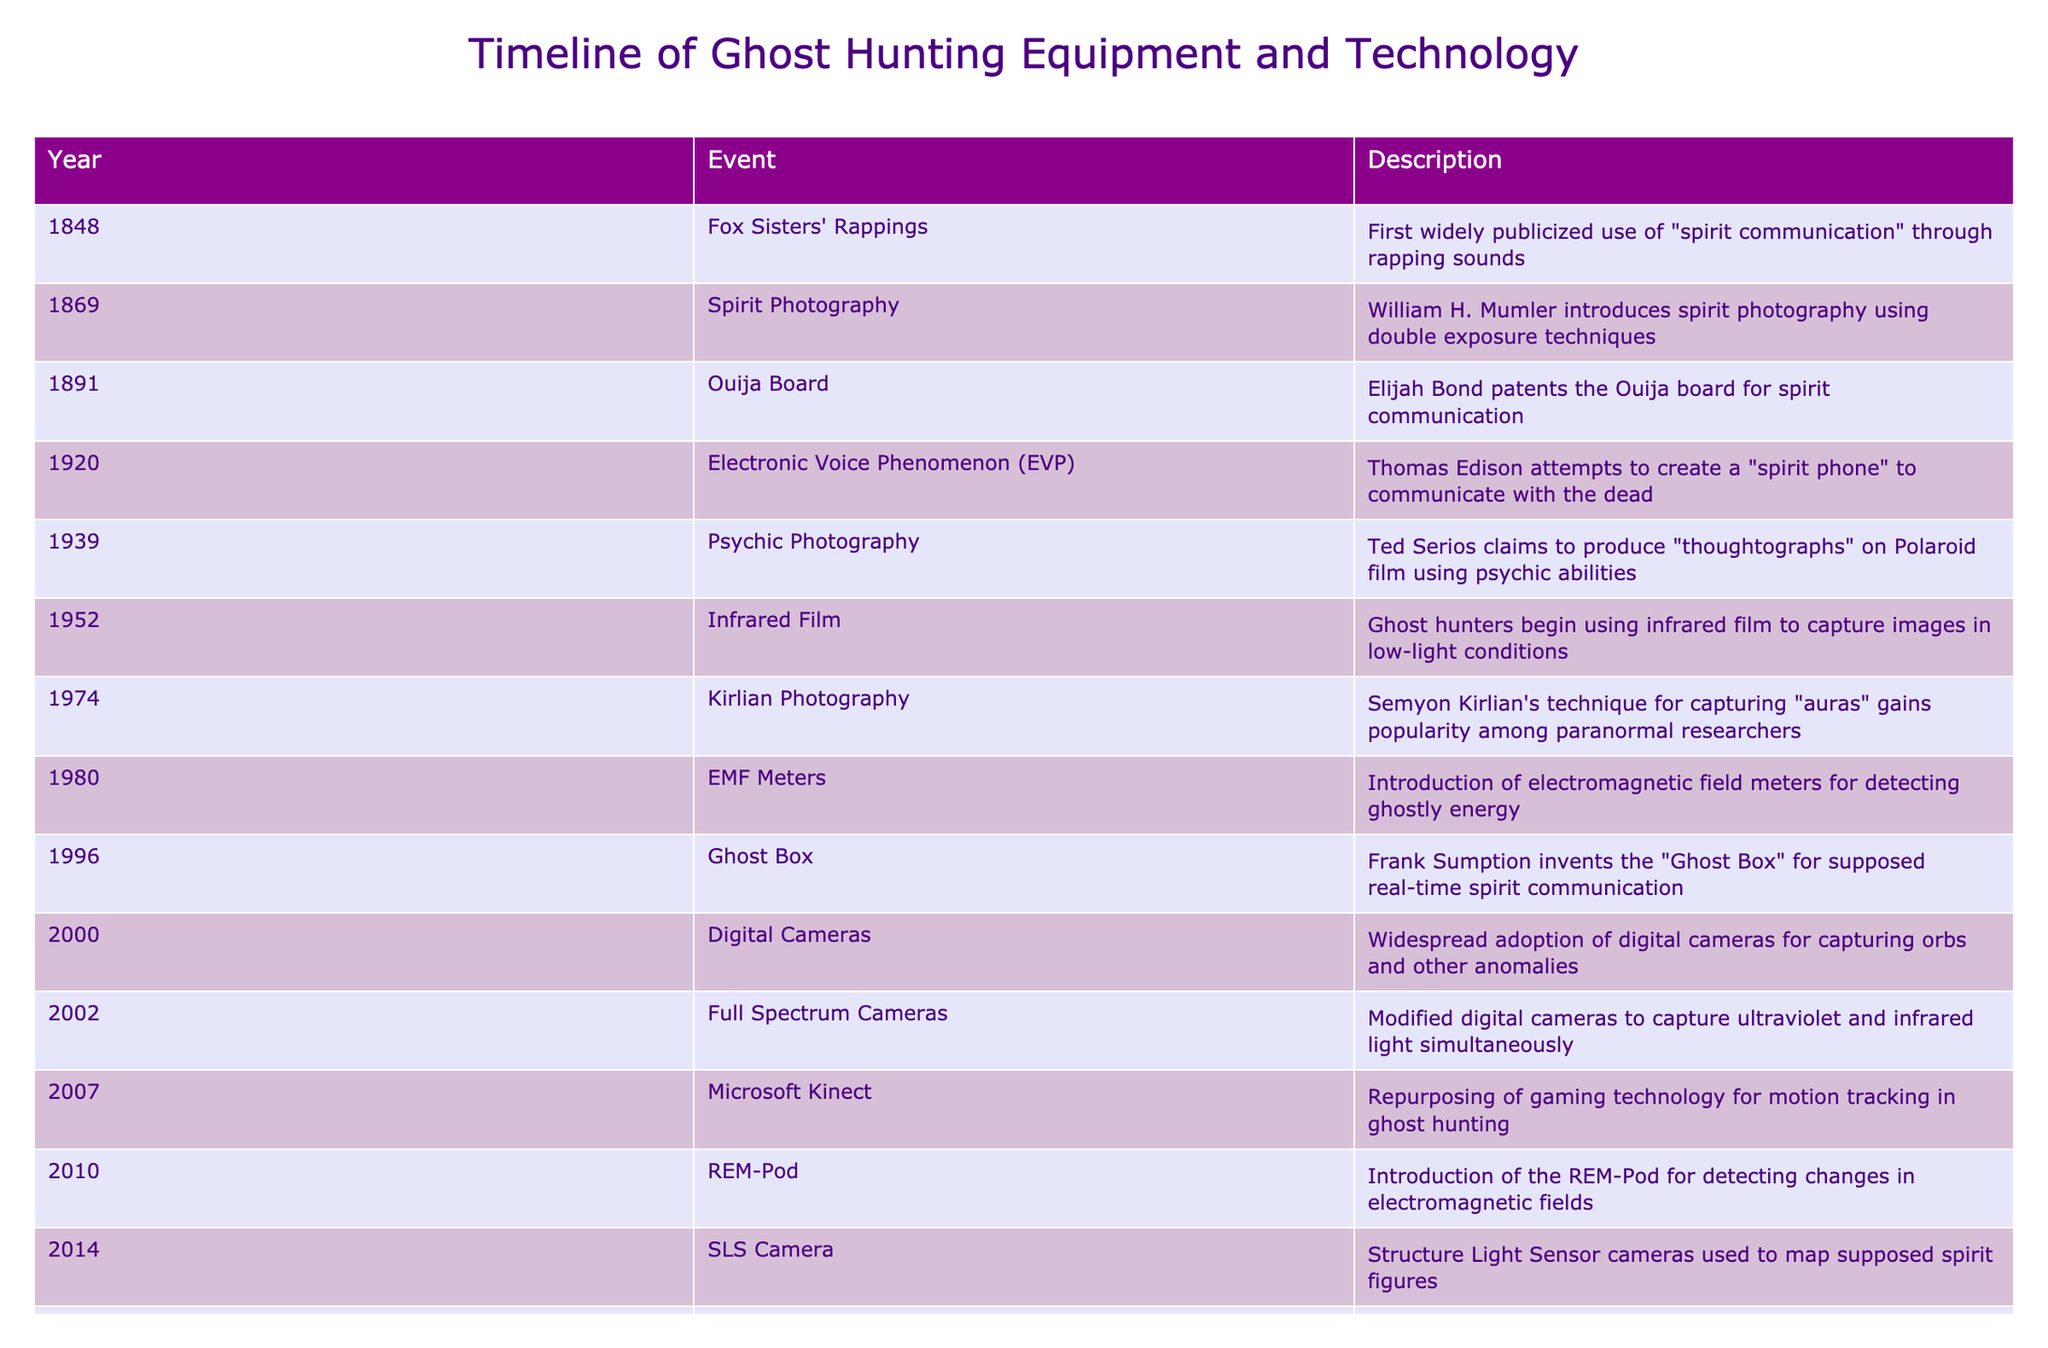What year was the Ouija board patented? The table lists that the Ouija board was patented in 1891.
Answer: 1891 Which event occurred first: spirit photography or electronic voice phenomenon? By checking the years, spirit photography occurred in 1869, and electronic voice phenomenon was attempted in 1920. Since 1869 is earlier than 1920, spirit photography occurred first.
Answer: Spirit photography How many years were there between the introduction of EMF meters and the Ghost Box invention? EMF meters were introduced in 1980, and the Ghost Box was invented in 1996. The difference between these two years is 1996 - 1980 = 16 years.
Answer: 16 years Did thermal imaging cameras become widely used before or after AI-enhanced analysis? Thermal imaging cameras gained popularity in 2018, while AI-enhanced analysis was implemented in 2020. Since 2020 is after 2018, thermal imaging cameras were used before AI-enhanced analysis.
Answer: Before Which technology was introduced in 2002? The table specifies that modified digital cameras to capture ultraviolet and infrared light simultaneously were introduced in 2002.
Answer: Full Spectrum Cameras How many different types of photography techniques are mentioned in this timeline? There are three distinct photography techniques: spirit photography (1869), psychic photography (1939), and Kirlian photography (1974). Therefore, we can count them as a total of three types of photography techniques mentioned.
Answer: 3 techniques Which event marked the first use of a device specifically designed for electromagnetic field detection? Referring to the table, the introduction of EMF meters in 1980 marked the first use of a device specifically designed for detecting electromagnetic fields.
Answer: EMF Meters What was the relationship between motion tracking technology and ghost hunting? The table states that in 2007, Microsoft Kinect was repurposed from gaming technology for motion tracking in ghost hunting, establishing a connection between the two fields.
Answer: Motion tracking technology was repurposed for ghost hunting What can be concluded about the progression of ghost hunting technology from 1848 to 2020? Observing the timeline, there has been a significant evolution in ghost hunting technology, starting from simple sound communication methods in 1848 to advanced AI-enhanced analysis by 2020, illustrating a trend of increasing sophistication and the integration of new technologies over time.
Answer: Increased sophistication of technology 